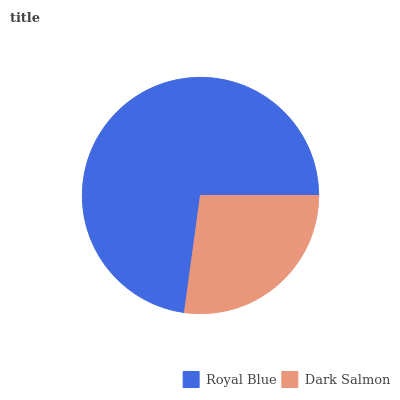Is Dark Salmon the minimum?
Answer yes or no. Yes. Is Royal Blue the maximum?
Answer yes or no. Yes. Is Dark Salmon the maximum?
Answer yes or no. No. Is Royal Blue greater than Dark Salmon?
Answer yes or no. Yes. Is Dark Salmon less than Royal Blue?
Answer yes or no. Yes. Is Dark Salmon greater than Royal Blue?
Answer yes or no. No. Is Royal Blue less than Dark Salmon?
Answer yes or no. No. Is Royal Blue the high median?
Answer yes or no. Yes. Is Dark Salmon the low median?
Answer yes or no. Yes. Is Dark Salmon the high median?
Answer yes or no. No. Is Royal Blue the low median?
Answer yes or no. No. 